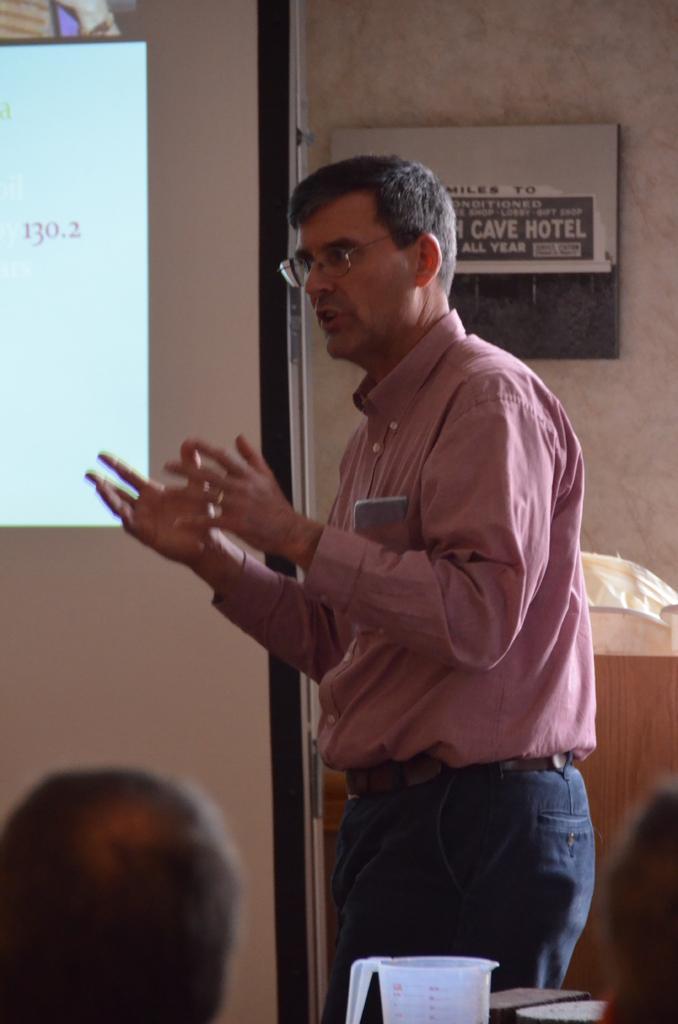How would you summarize this image in a sentence or two? In this picture we can see a person standing and talking, we can see a person head, mug and display on the board. 